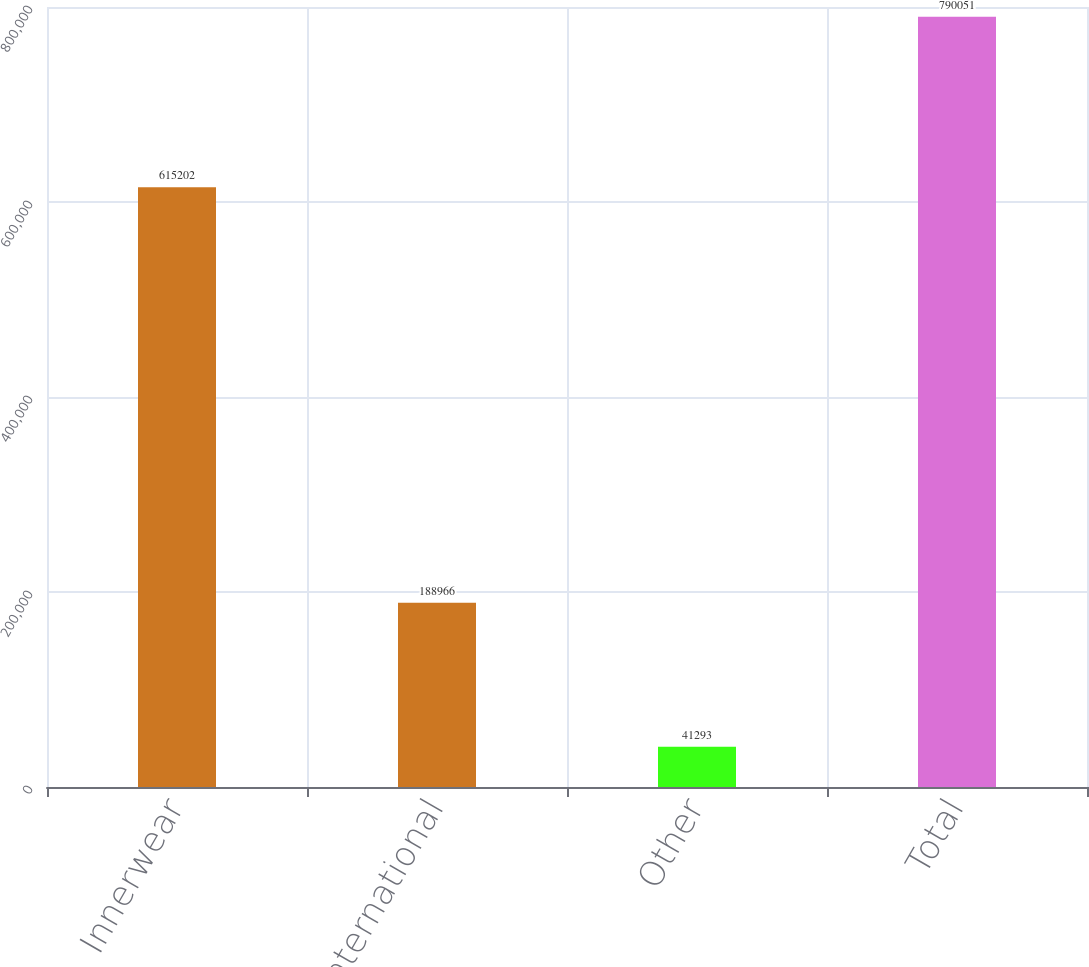Convert chart. <chart><loc_0><loc_0><loc_500><loc_500><bar_chart><fcel>Innerwear<fcel>International<fcel>Other<fcel>Total<nl><fcel>615202<fcel>188966<fcel>41293<fcel>790051<nl></chart> 